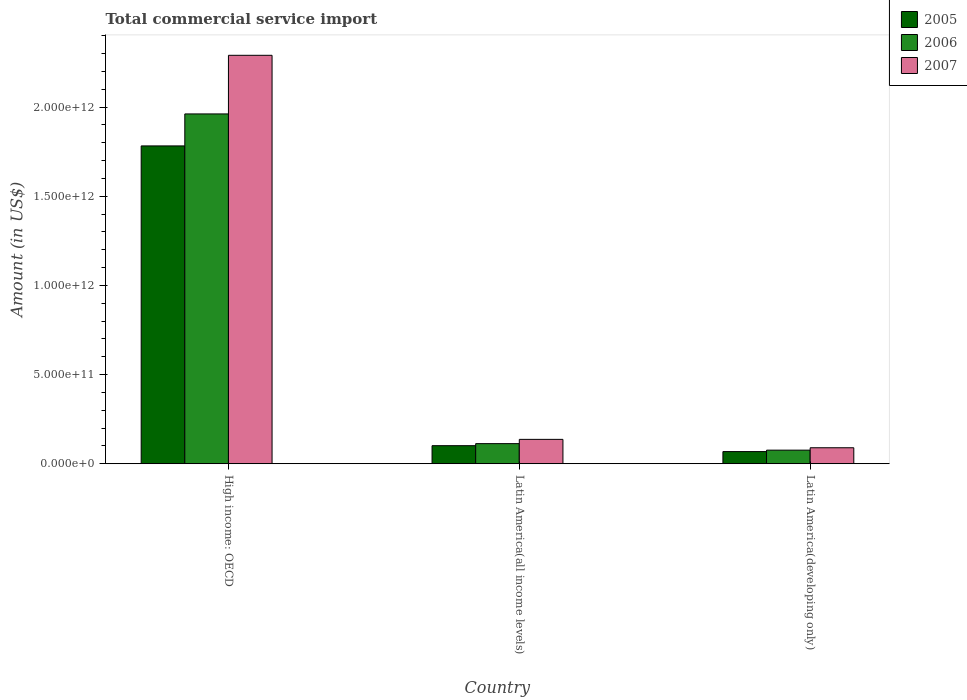Are the number of bars per tick equal to the number of legend labels?
Offer a terse response. Yes. How many bars are there on the 2nd tick from the left?
Your response must be concise. 3. What is the label of the 3rd group of bars from the left?
Make the answer very short. Latin America(developing only). In how many cases, is the number of bars for a given country not equal to the number of legend labels?
Provide a succinct answer. 0. What is the total commercial service import in 2007 in Latin America(all income levels)?
Offer a terse response. 1.37e+11. Across all countries, what is the maximum total commercial service import in 2006?
Your response must be concise. 1.96e+12. Across all countries, what is the minimum total commercial service import in 2005?
Your answer should be very brief. 6.81e+1. In which country was the total commercial service import in 2007 maximum?
Offer a very short reply. High income: OECD. In which country was the total commercial service import in 2005 minimum?
Offer a terse response. Latin America(developing only). What is the total total commercial service import in 2006 in the graph?
Offer a terse response. 2.15e+12. What is the difference between the total commercial service import in 2005 in Latin America(all income levels) and that in Latin America(developing only)?
Ensure brevity in your answer.  3.31e+1. What is the difference between the total commercial service import in 2007 in Latin America(all income levels) and the total commercial service import in 2005 in Latin America(developing only)?
Keep it short and to the point. 6.85e+1. What is the average total commercial service import in 2006 per country?
Keep it short and to the point. 7.17e+11. What is the difference between the total commercial service import of/in 2005 and total commercial service import of/in 2006 in High income: OECD?
Give a very brief answer. -1.79e+11. What is the ratio of the total commercial service import in 2007 in High income: OECD to that in Latin America(developing only)?
Offer a terse response. 25.55. Is the total commercial service import in 2005 in Latin America(all income levels) less than that in Latin America(developing only)?
Your response must be concise. No. Is the difference between the total commercial service import in 2005 in High income: OECD and Latin America(all income levels) greater than the difference between the total commercial service import in 2006 in High income: OECD and Latin America(all income levels)?
Your answer should be compact. No. What is the difference between the highest and the second highest total commercial service import in 2005?
Give a very brief answer. -1.71e+12. What is the difference between the highest and the lowest total commercial service import in 2006?
Offer a very short reply. 1.89e+12. Is the sum of the total commercial service import in 2007 in Latin America(all income levels) and Latin America(developing only) greater than the maximum total commercial service import in 2006 across all countries?
Make the answer very short. No. What does the 2nd bar from the left in High income: OECD represents?
Provide a succinct answer. 2006. What does the 1st bar from the right in High income: OECD represents?
Make the answer very short. 2007. Is it the case that in every country, the sum of the total commercial service import in 2006 and total commercial service import in 2005 is greater than the total commercial service import in 2007?
Your answer should be compact. Yes. How many countries are there in the graph?
Your answer should be compact. 3. What is the difference between two consecutive major ticks on the Y-axis?
Your answer should be compact. 5.00e+11. Does the graph contain grids?
Give a very brief answer. No. Where does the legend appear in the graph?
Ensure brevity in your answer.  Top right. How many legend labels are there?
Your answer should be compact. 3. What is the title of the graph?
Your response must be concise. Total commercial service import. Does "1988" appear as one of the legend labels in the graph?
Your response must be concise. No. What is the label or title of the X-axis?
Offer a very short reply. Country. What is the label or title of the Y-axis?
Give a very brief answer. Amount (in US$). What is the Amount (in US$) of 2005 in High income: OECD?
Make the answer very short. 1.78e+12. What is the Amount (in US$) of 2006 in High income: OECD?
Provide a succinct answer. 1.96e+12. What is the Amount (in US$) in 2007 in High income: OECD?
Your response must be concise. 2.29e+12. What is the Amount (in US$) of 2005 in Latin America(all income levels)?
Offer a terse response. 1.01e+11. What is the Amount (in US$) of 2006 in Latin America(all income levels)?
Offer a terse response. 1.13e+11. What is the Amount (in US$) in 2007 in Latin America(all income levels)?
Ensure brevity in your answer.  1.37e+11. What is the Amount (in US$) of 2005 in Latin America(developing only)?
Provide a succinct answer. 6.81e+1. What is the Amount (in US$) of 2006 in Latin America(developing only)?
Keep it short and to the point. 7.62e+1. What is the Amount (in US$) in 2007 in Latin America(developing only)?
Your answer should be compact. 8.96e+1. Across all countries, what is the maximum Amount (in US$) in 2005?
Provide a short and direct response. 1.78e+12. Across all countries, what is the maximum Amount (in US$) of 2006?
Provide a short and direct response. 1.96e+12. Across all countries, what is the maximum Amount (in US$) of 2007?
Offer a terse response. 2.29e+12. Across all countries, what is the minimum Amount (in US$) in 2005?
Your answer should be very brief. 6.81e+1. Across all countries, what is the minimum Amount (in US$) of 2006?
Your answer should be compact. 7.62e+1. Across all countries, what is the minimum Amount (in US$) of 2007?
Offer a very short reply. 8.96e+1. What is the total Amount (in US$) in 2005 in the graph?
Provide a succinct answer. 1.95e+12. What is the total Amount (in US$) in 2006 in the graph?
Your answer should be very brief. 2.15e+12. What is the total Amount (in US$) of 2007 in the graph?
Your response must be concise. 2.52e+12. What is the difference between the Amount (in US$) in 2005 in High income: OECD and that in Latin America(all income levels)?
Offer a very short reply. 1.68e+12. What is the difference between the Amount (in US$) in 2006 in High income: OECD and that in Latin America(all income levels)?
Make the answer very short. 1.85e+12. What is the difference between the Amount (in US$) in 2007 in High income: OECD and that in Latin America(all income levels)?
Ensure brevity in your answer.  2.15e+12. What is the difference between the Amount (in US$) of 2005 in High income: OECD and that in Latin America(developing only)?
Keep it short and to the point. 1.71e+12. What is the difference between the Amount (in US$) in 2006 in High income: OECD and that in Latin America(developing only)?
Your response must be concise. 1.89e+12. What is the difference between the Amount (in US$) of 2007 in High income: OECD and that in Latin America(developing only)?
Provide a short and direct response. 2.20e+12. What is the difference between the Amount (in US$) of 2005 in Latin America(all income levels) and that in Latin America(developing only)?
Provide a succinct answer. 3.31e+1. What is the difference between the Amount (in US$) of 2006 in Latin America(all income levels) and that in Latin America(developing only)?
Keep it short and to the point. 3.65e+1. What is the difference between the Amount (in US$) in 2007 in Latin America(all income levels) and that in Latin America(developing only)?
Your answer should be compact. 4.71e+1. What is the difference between the Amount (in US$) in 2005 in High income: OECD and the Amount (in US$) in 2006 in Latin America(all income levels)?
Make the answer very short. 1.67e+12. What is the difference between the Amount (in US$) in 2005 in High income: OECD and the Amount (in US$) in 2007 in Latin America(all income levels)?
Keep it short and to the point. 1.65e+12. What is the difference between the Amount (in US$) in 2006 in High income: OECD and the Amount (in US$) in 2007 in Latin America(all income levels)?
Ensure brevity in your answer.  1.82e+12. What is the difference between the Amount (in US$) in 2005 in High income: OECD and the Amount (in US$) in 2006 in Latin America(developing only)?
Your answer should be very brief. 1.71e+12. What is the difference between the Amount (in US$) of 2005 in High income: OECD and the Amount (in US$) of 2007 in Latin America(developing only)?
Offer a very short reply. 1.69e+12. What is the difference between the Amount (in US$) in 2006 in High income: OECD and the Amount (in US$) in 2007 in Latin America(developing only)?
Your response must be concise. 1.87e+12. What is the difference between the Amount (in US$) in 2005 in Latin America(all income levels) and the Amount (in US$) in 2006 in Latin America(developing only)?
Your answer should be compact. 2.50e+1. What is the difference between the Amount (in US$) in 2005 in Latin America(all income levels) and the Amount (in US$) in 2007 in Latin America(developing only)?
Make the answer very short. 1.16e+1. What is the difference between the Amount (in US$) of 2006 in Latin America(all income levels) and the Amount (in US$) of 2007 in Latin America(developing only)?
Provide a short and direct response. 2.31e+1. What is the average Amount (in US$) of 2005 per country?
Your response must be concise. 6.50e+11. What is the average Amount (in US$) of 2006 per country?
Keep it short and to the point. 7.17e+11. What is the average Amount (in US$) of 2007 per country?
Keep it short and to the point. 8.39e+11. What is the difference between the Amount (in US$) in 2005 and Amount (in US$) in 2006 in High income: OECD?
Your answer should be compact. -1.79e+11. What is the difference between the Amount (in US$) in 2005 and Amount (in US$) in 2007 in High income: OECD?
Offer a terse response. -5.08e+11. What is the difference between the Amount (in US$) of 2006 and Amount (in US$) of 2007 in High income: OECD?
Provide a succinct answer. -3.29e+11. What is the difference between the Amount (in US$) in 2005 and Amount (in US$) in 2006 in Latin America(all income levels)?
Give a very brief answer. -1.15e+1. What is the difference between the Amount (in US$) of 2005 and Amount (in US$) of 2007 in Latin America(all income levels)?
Give a very brief answer. -3.55e+1. What is the difference between the Amount (in US$) of 2006 and Amount (in US$) of 2007 in Latin America(all income levels)?
Your answer should be compact. -2.40e+1. What is the difference between the Amount (in US$) of 2005 and Amount (in US$) of 2006 in Latin America(developing only)?
Your response must be concise. -8.08e+09. What is the difference between the Amount (in US$) in 2005 and Amount (in US$) in 2007 in Latin America(developing only)?
Ensure brevity in your answer.  -2.15e+1. What is the difference between the Amount (in US$) in 2006 and Amount (in US$) in 2007 in Latin America(developing only)?
Make the answer very short. -1.34e+1. What is the ratio of the Amount (in US$) in 2005 in High income: OECD to that in Latin America(all income levels)?
Your answer should be very brief. 17.6. What is the ratio of the Amount (in US$) of 2006 in High income: OECD to that in Latin America(all income levels)?
Your response must be concise. 17.4. What is the ratio of the Amount (in US$) in 2007 in High income: OECD to that in Latin America(all income levels)?
Offer a terse response. 16.75. What is the ratio of the Amount (in US$) of 2005 in High income: OECD to that in Latin America(developing only)?
Provide a succinct answer. 26.15. What is the ratio of the Amount (in US$) in 2006 in High income: OECD to that in Latin America(developing only)?
Make the answer very short. 25.73. What is the ratio of the Amount (in US$) of 2007 in High income: OECD to that in Latin America(developing only)?
Keep it short and to the point. 25.55. What is the ratio of the Amount (in US$) in 2005 in Latin America(all income levels) to that in Latin America(developing only)?
Ensure brevity in your answer.  1.49. What is the ratio of the Amount (in US$) of 2006 in Latin America(all income levels) to that in Latin America(developing only)?
Provide a short and direct response. 1.48. What is the ratio of the Amount (in US$) of 2007 in Latin America(all income levels) to that in Latin America(developing only)?
Provide a succinct answer. 1.53. What is the difference between the highest and the second highest Amount (in US$) of 2005?
Keep it short and to the point. 1.68e+12. What is the difference between the highest and the second highest Amount (in US$) of 2006?
Ensure brevity in your answer.  1.85e+12. What is the difference between the highest and the second highest Amount (in US$) in 2007?
Offer a very short reply. 2.15e+12. What is the difference between the highest and the lowest Amount (in US$) of 2005?
Provide a short and direct response. 1.71e+12. What is the difference between the highest and the lowest Amount (in US$) in 2006?
Your answer should be very brief. 1.89e+12. What is the difference between the highest and the lowest Amount (in US$) of 2007?
Give a very brief answer. 2.20e+12. 